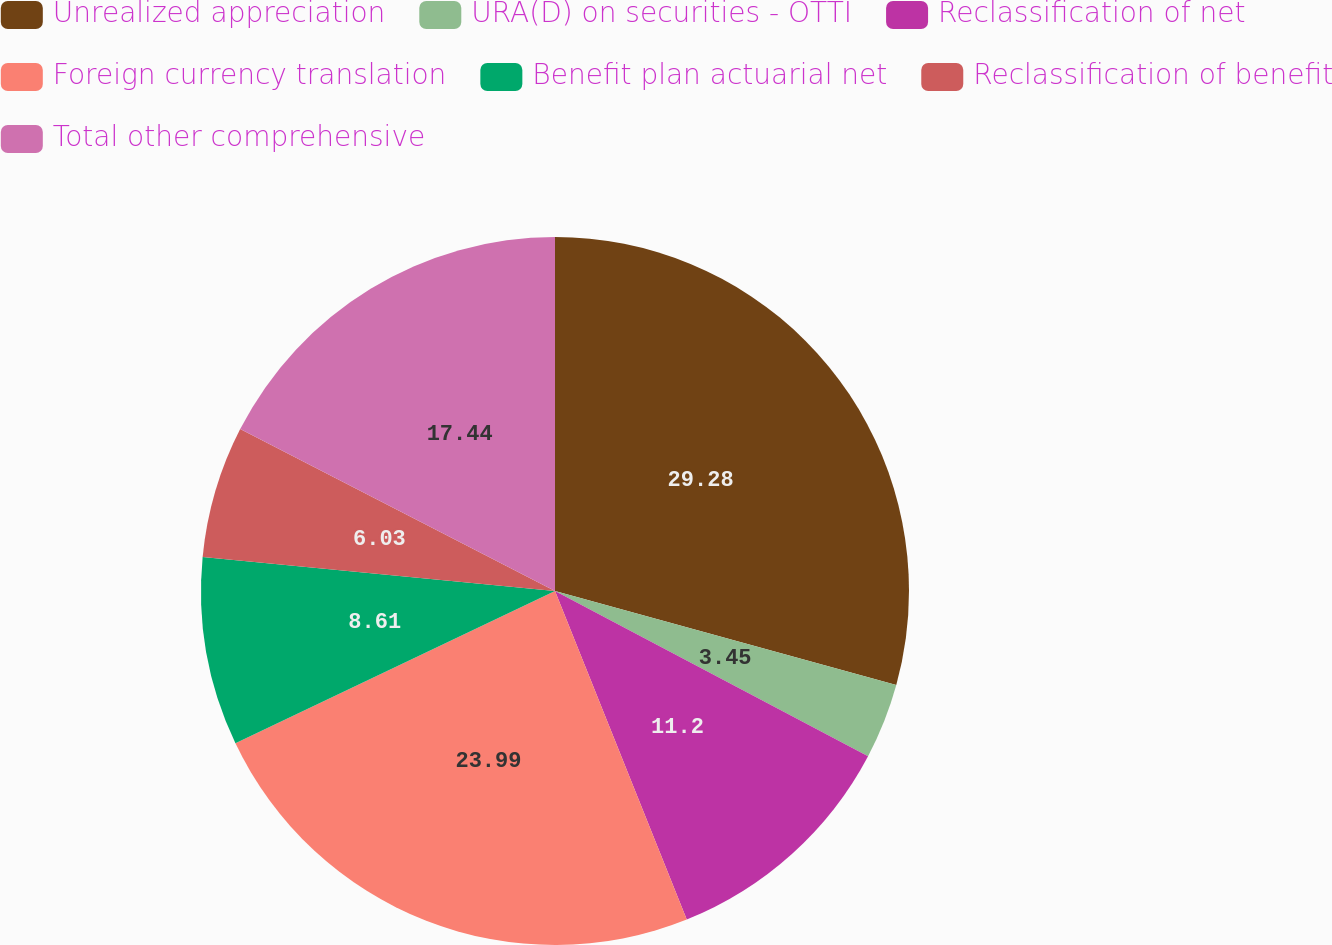<chart> <loc_0><loc_0><loc_500><loc_500><pie_chart><fcel>Unrealized appreciation<fcel>URA(D) on securities - OTTI<fcel>Reclassification of net<fcel>Foreign currency translation<fcel>Benefit plan actuarial net<fcel>Reclassification of benefit<fcel>Total other comprehensive<nl><fcel>29.28%<fcel>3.45%<fcel>11.2%<fcel>23.99%<fcel>8.61%<fcel>6.03%<fcel>17.44%<nl></chart> 